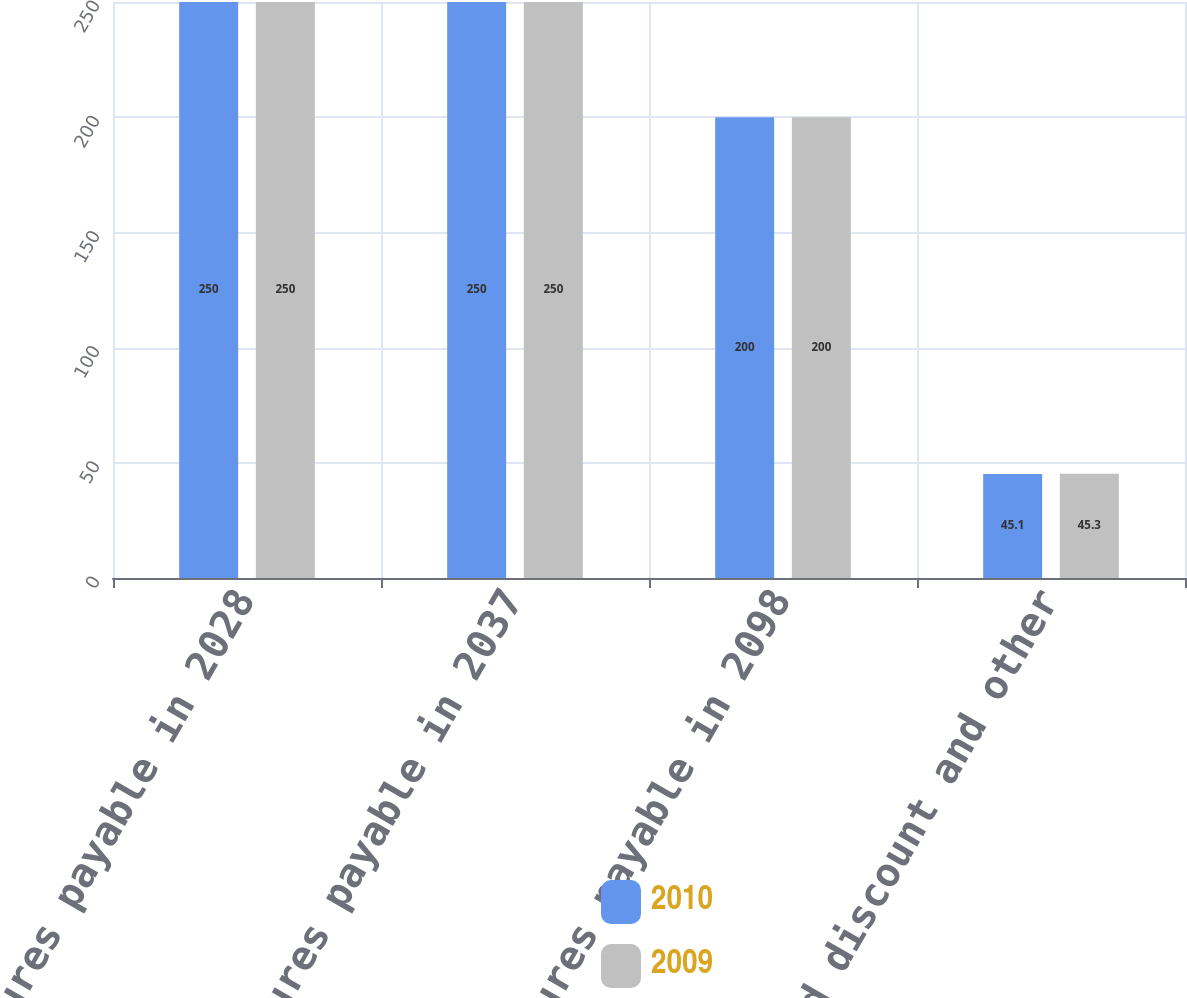Convert chart to OTSL. <chart><loc_0><loc_0><loc_500><loc_500><stacked_bar_chart><ecel><fcel>670 debentures payable in 2028<fcel>625 debentures payable in 2037<fcel>520 debentures payable in 2098<fcel>Unamortized discount and other<nl><fcel>2010<fcel>250<fcel>250<fcel>200<fcel>45.1<nl><fcel>2009<fcel>250<fcel>250<fcel>200<fcel>45.3<nl></chart> 